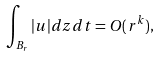<formula> <loc_0><loc_0><loc_500><loc_500>\int _ { B _ { r } } | u | d z d t = O ( r ^ { k } ) , \</formula> 